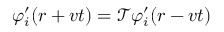Convert formula to latex. <formula><loc_0><loc_0><loc_500><loc_500>\varphi _ { i } ^ { \prime } ( r + v t ) = \mathcal { T } \varphi _ { i } ^ { \prime } ( r - v t )</formula> 